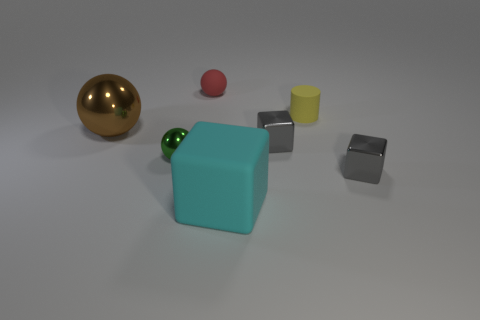There is a tiny gray object that is behind the green thing; is there a small sphere right of it?
Provide a short and direct response. No. Is the number of small gray cubes that are on the left side of the tiny yellow rubber cylinder greater than the number of big rubber things in front of the rubber sphere?
Make the answer very short. No. How many small metal things have the same color as the big sphere?
Your answer should be very brief. 0. There is a big thing behind the large cyan rubber block; is its color the same as the large object in front of the brown object?
Keep it short and to the point. No. There is a large block; are there any blocks on the right side of it?
Your response must be concise. Yes. What is the material of the big cyan cube?
Provide a short and direct response. Rubber. What shape is the large thing that is in front of the big metallic thing?
Make the answer very short. Cube. Are there any purple cylinders of the same size as the red ball?
Provide a short and direct response. No. Are the green thing to the left of the yellow object and the large cyan object made of the same material?
Offer a very short reply. No. Are there the same number of spheres in front of the tiny red rubber sphere and big cyan objects in front of the cyan block?
Make the answer very short. No. 